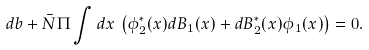Convert formula to latex. <formula><loc_0><loc_0><loc_500><loc_500>d b + \bar { N } \Pi \int d x \, \left ( \phi _ { 2 } ^ { * } ( x ) d B _ { 1 } ( x ) + d B _ { 2 } ^ { * } ( x ) \phi _ { 1 } ( x ) \right ) = 0 .</formula> 